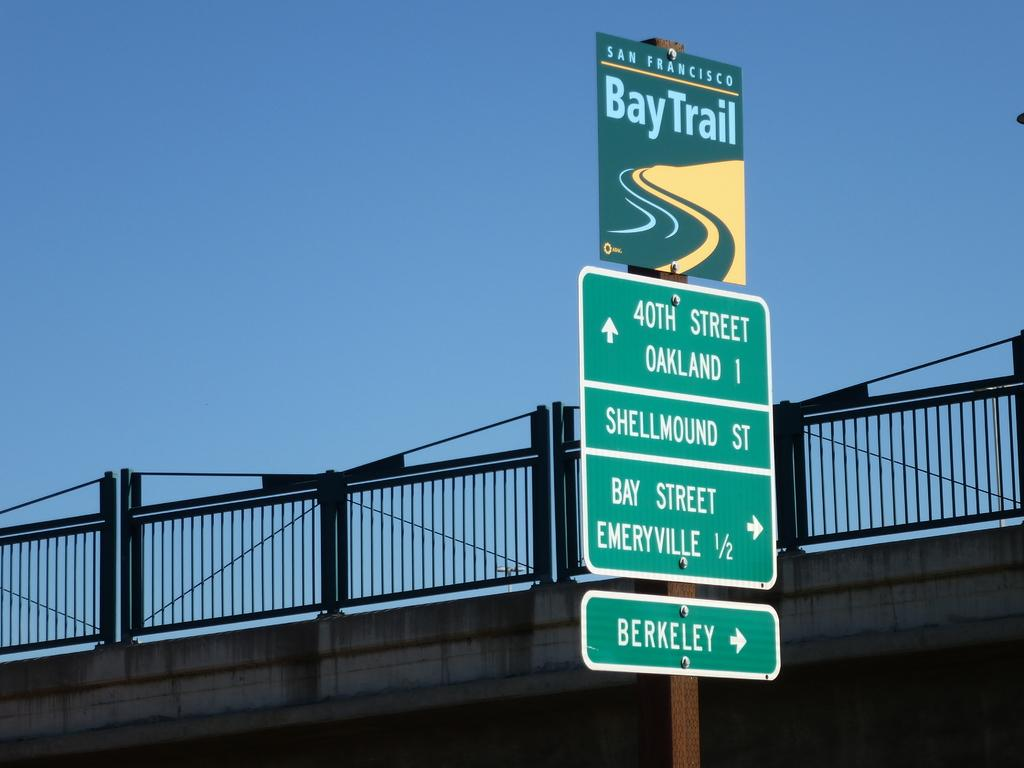<image>
Relay a brief, clear account of the picture shown. A row of green street signs are beneath another sign that says San Francisco Bay Trail. 